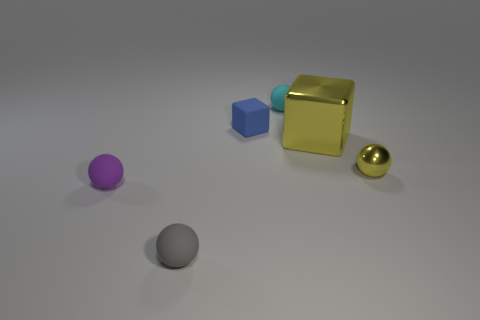How many other objects are there of the same color as the large cube?
Your answer should be very brief. 1. Is there anything else that has the same size as the shiny block?
Give a very brief answer. No. Is the color of the big block the same as the small metal thing?
Your response must be concise. Yes. There is a small object on the right side of the small ball that is behind the yellow metal thing to the right of the big yellow thing; what is its shape?
Give a very brief answer. Sphere. There is a ball that is in front of the blue matte object and to the right of the blue matte block; what size is it?
Provide a succinct answer. Small. Are there fewer big metal things than tiny spheres?
Give a very brief answer. Yes. What is the size of the cube that is in front of the tiny blue block?
Provide a short and direct response. Large. There is a small thing that is in front of the small yellow sphere and behind the gray sphere; what is its shape?
Your response must be concise. Sphere. What size is the cyan object that is the same shape as the purple matte thing?
Your answer should be very brief. Small. What number of things have the same material as the tiny purple sphere?
Keep it short and to the point. 3. 